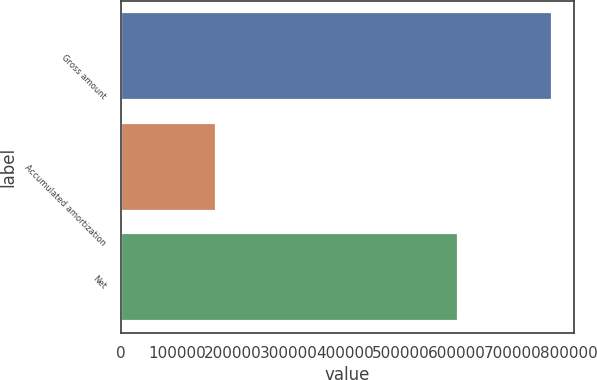<chart> <loc_0><loc_0><loc_500><loc_500><bar_chart><fcel>Gross amount<fcel>Accumulated amortization<fcel>Net<nl><fcel>770855<fcel>169623<fcel>601232<nl></chart> 